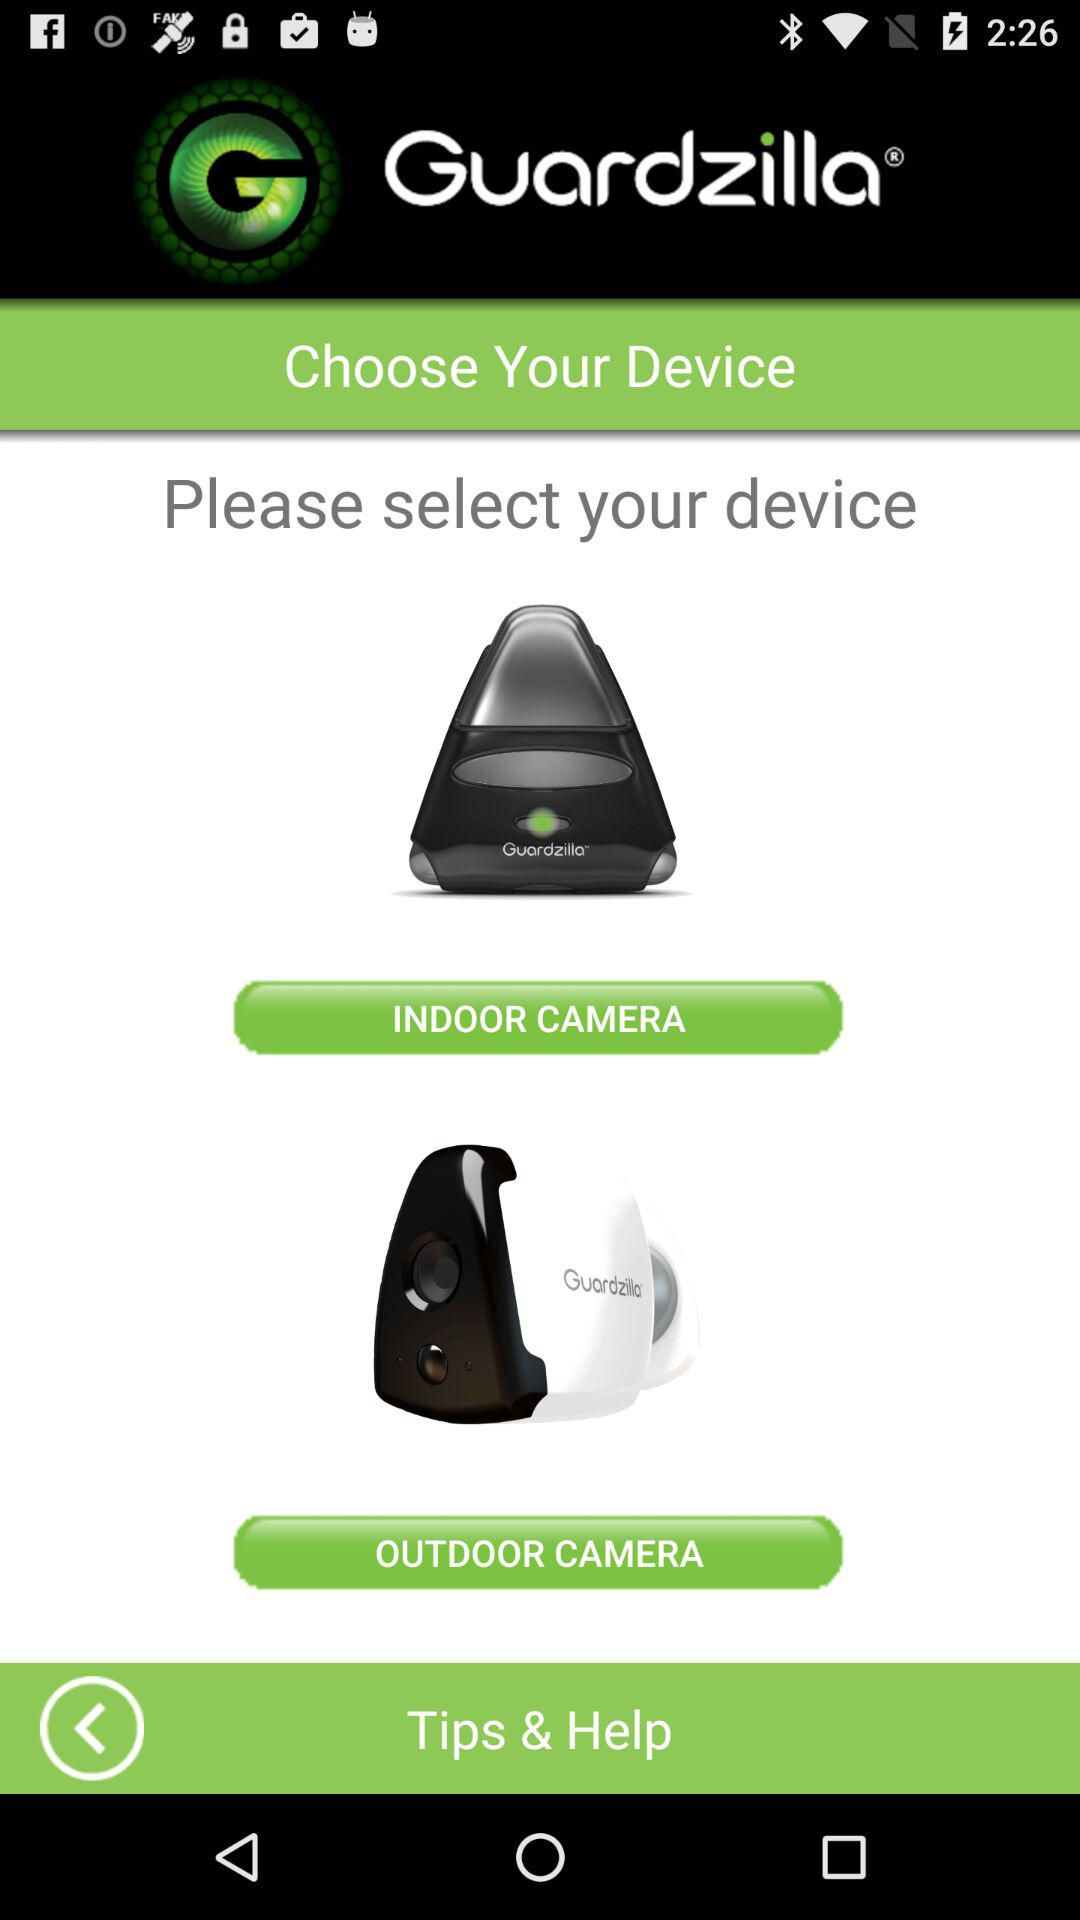What is the name of the application? The name of the application is "Guardzilla®". 